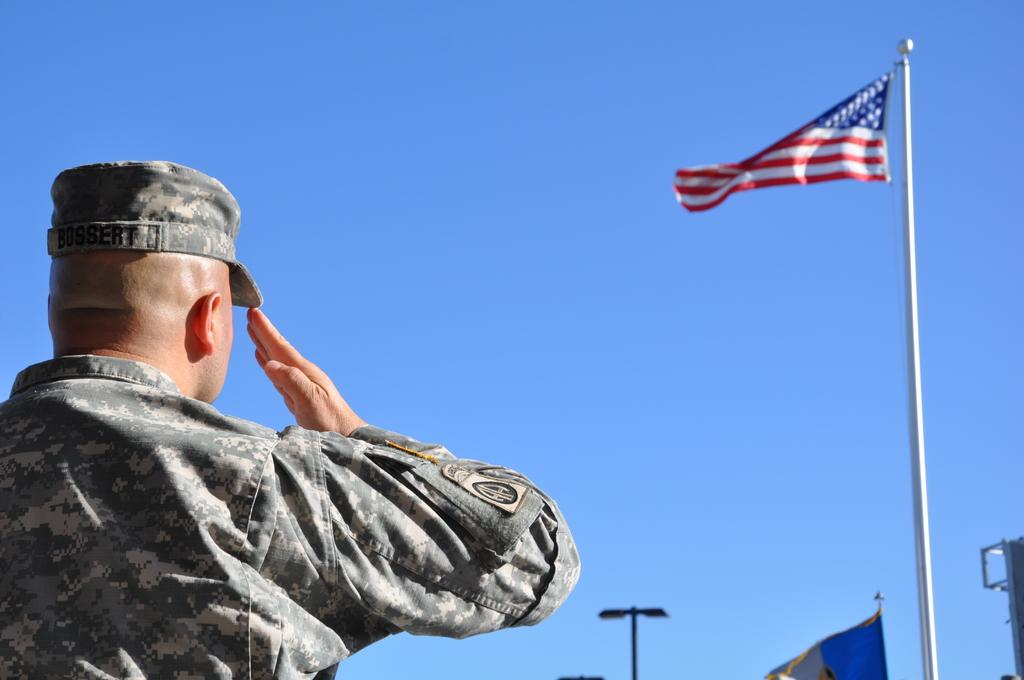What is located on the left side of the image? There is a man on the left side of the image. What is in front of the man? There are flags and metal rods in front of the man. What type of songs can be heard coming from the lizards in the image? There are no lizards present in the image, so it's not possible to determine what, if any, songs might be heard. 